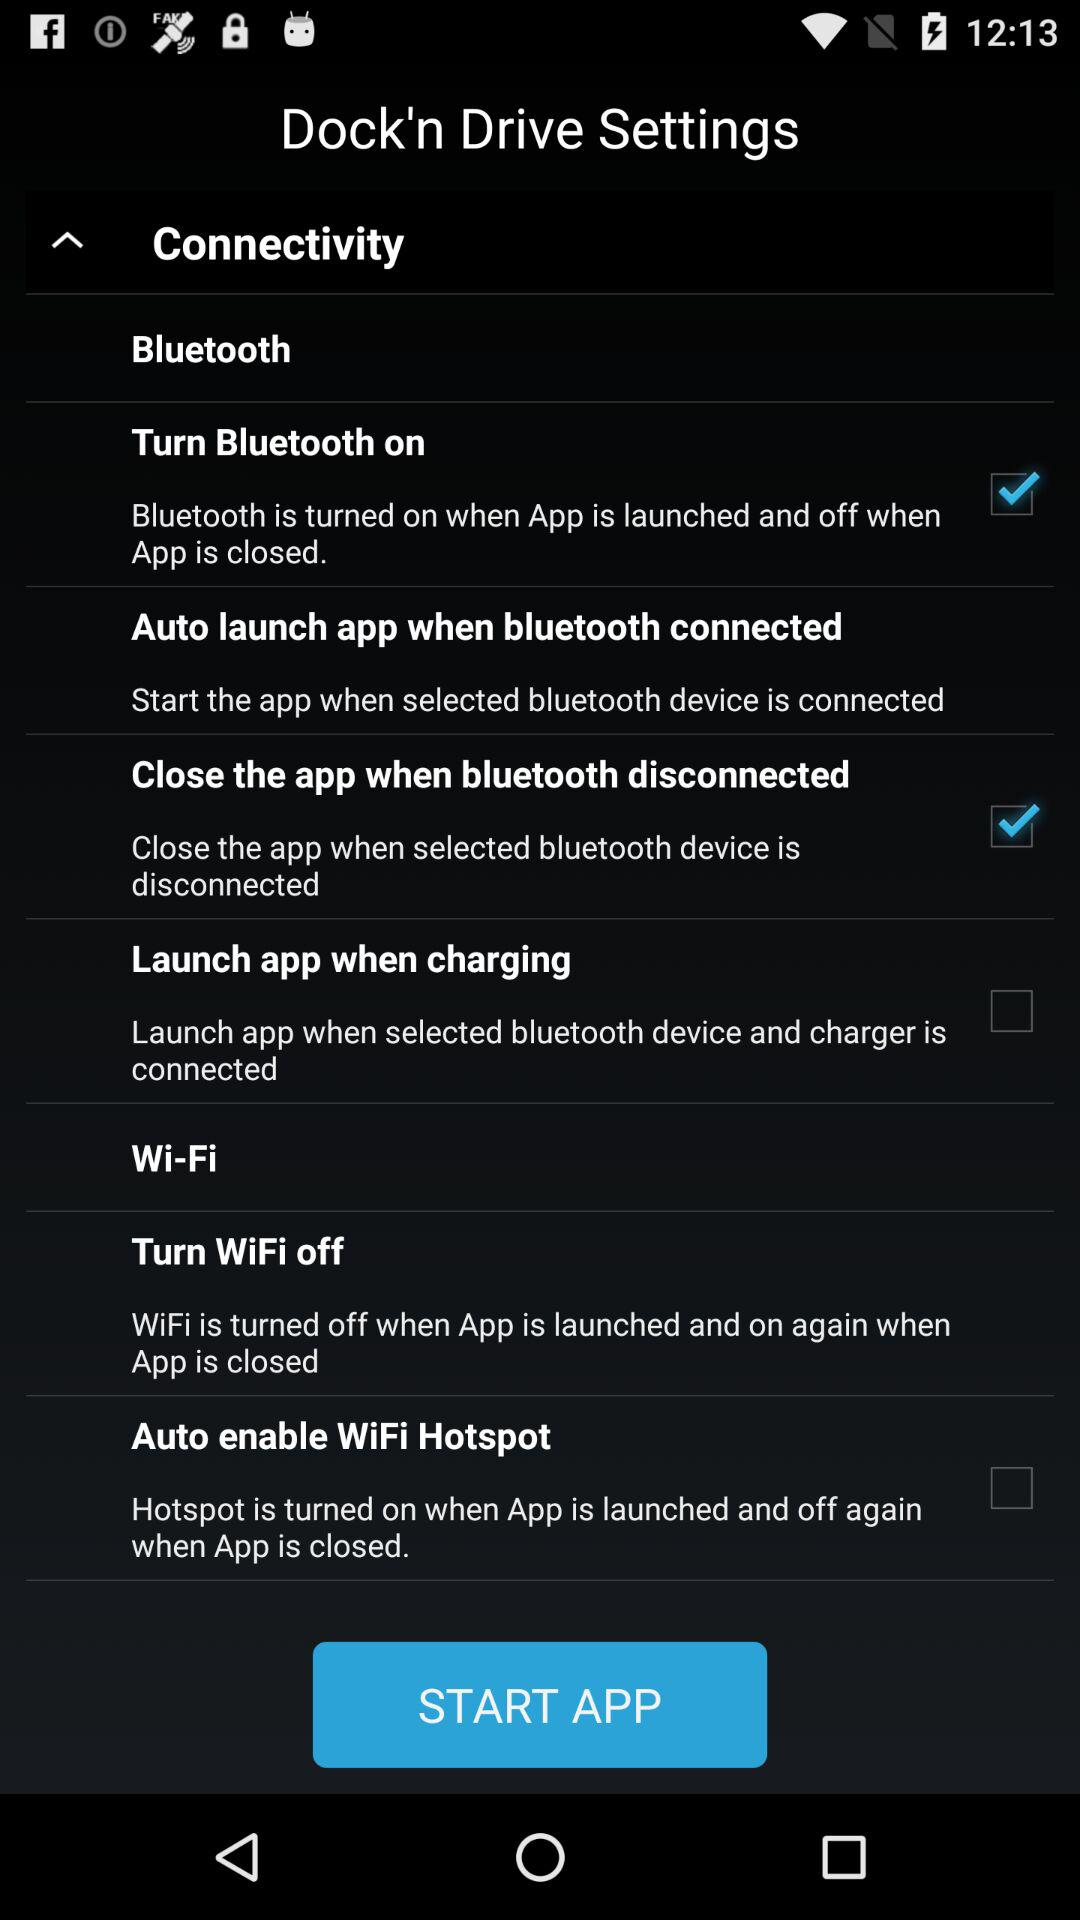What's the status of "Auto enable WiFi Hotspot"? The status of "Auto enable WiFi Hotspot" is "off". 